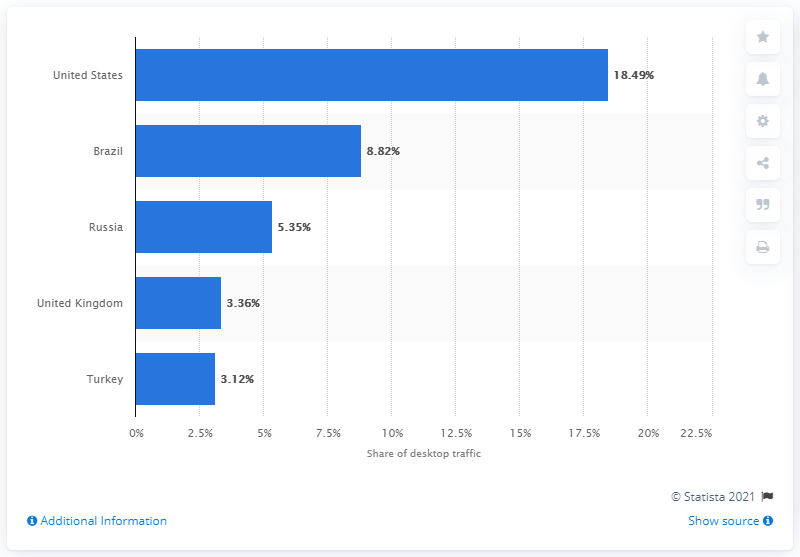Point out several critical features in this image. The United States has the highest amount of desktop traffic on Instagram. The total percentage of desktop traffic on Instagram for Brazil and the US is 27.31%. 